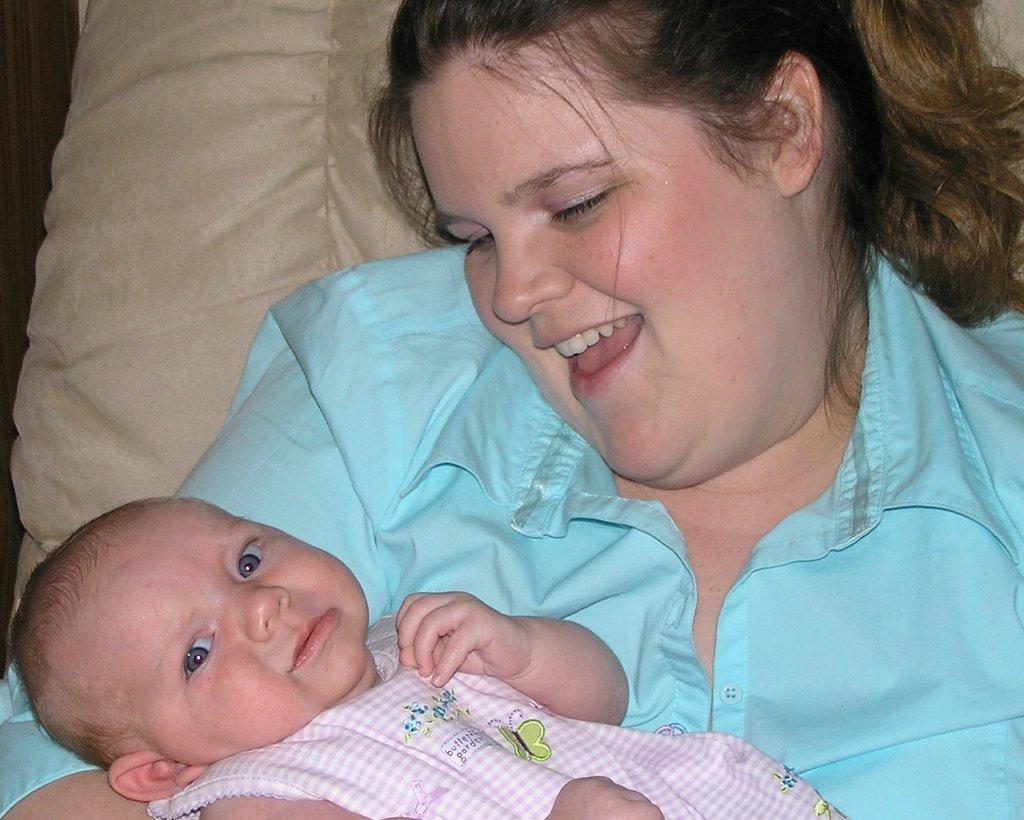Can you describe this image briefly? In this image I can see the person holding the baby and the person is wearing blue color shirt. In the background I can see the cream color cloth. 